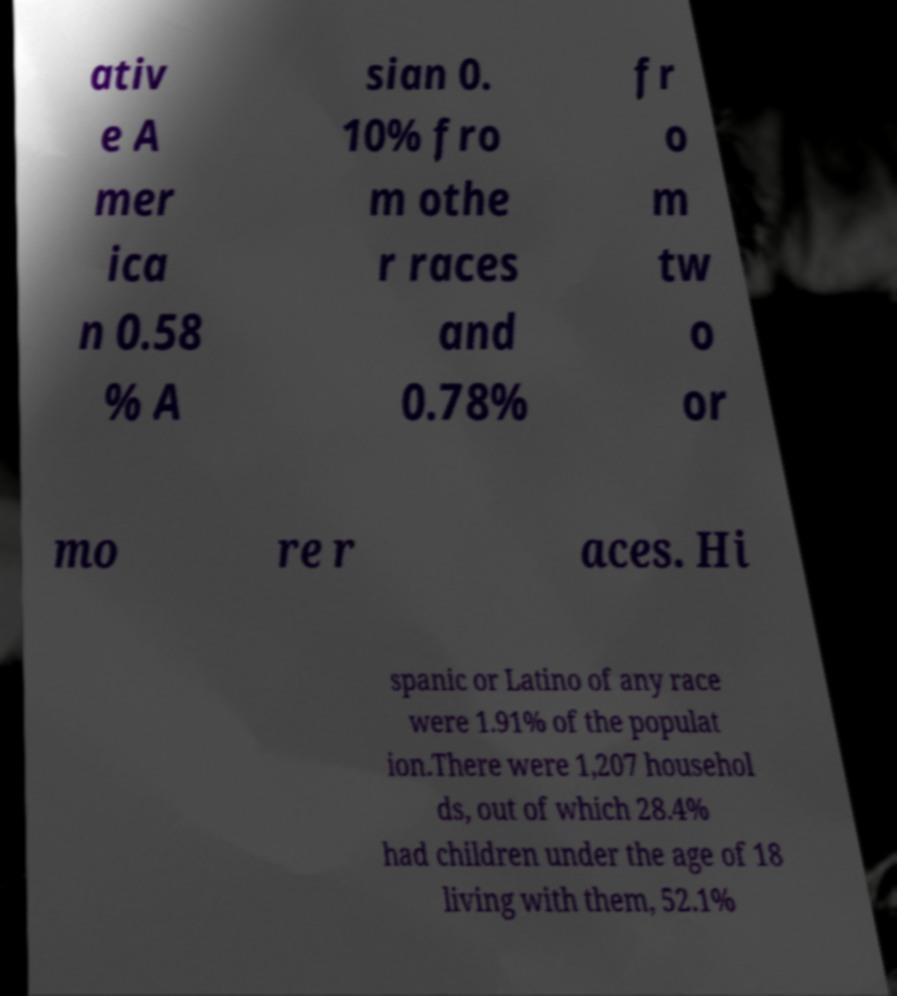There's text embedded in this image that I need extracted. Can you transcribe it verbatim? ativ e A mer ica n 0.58 % A sian 0. 10% fro m othe r races and 0.78% fr o m tw o or mo re r aces. Hi spanic or Latino of any race were 1.91% of the populat ion.There were 1,207 househol ds, out of which 28.4% had children under the age of 18 living with them, 52.1% 